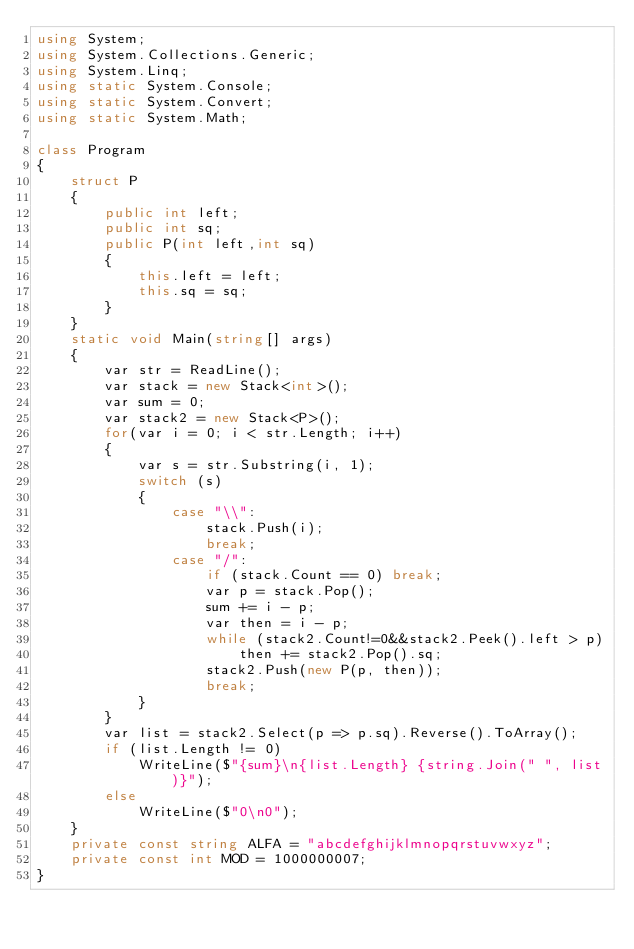Convert code to text. <code><loc_0><loc_0><loc_500><loc_500><_C#_>using System;
using System.Collections.Generic;
using System.Linq;
using static System.Console;
using static System.Convert;
using static System.Math;

class Program
{
    struct P
    {
        public int left;
        public int sq;
        public P(int left,int sq)
        {
            this.left = left;
            this.sq = sq;
        }
    }
    static void Main(string[] args)
    {
        var str = ReadLine();
        var stack = new Stack<int>();
        var sum = 0;
        var stack2 = new Stack<P>();
        for(var i = 0; i < str.Length; i++)
        {
            var s = str.Substring(i, 1);
            switch (s)
            {
                case "\\":
                    stack.Push(i);
                    break;
                case "/":
                    if (stack.Count == 0) break;
                    var p = stack.Pop();
                    sum += i - p;
                    var then = i - p;
                    while (stack2.Count!=0&&stack2.Peek().left > p)
                        then += stack2.Pop().sq;
                    stack2.Push(new P(p, then));
                    break;
            }
        }
        var list = stack2.Select(p => p.sq).Reverse().ToArray();
        if (list.Length != 0)
            WriteLine($"{sum}\n{list.Length} {string.Join(" ", list)}");
        else
            WriteLine($"0\n0");
    }
    private const string ALFA = "abcdefghijklmnopqrstuvwxyz";
    private const int MOD = 1000000007;
}

</code> 